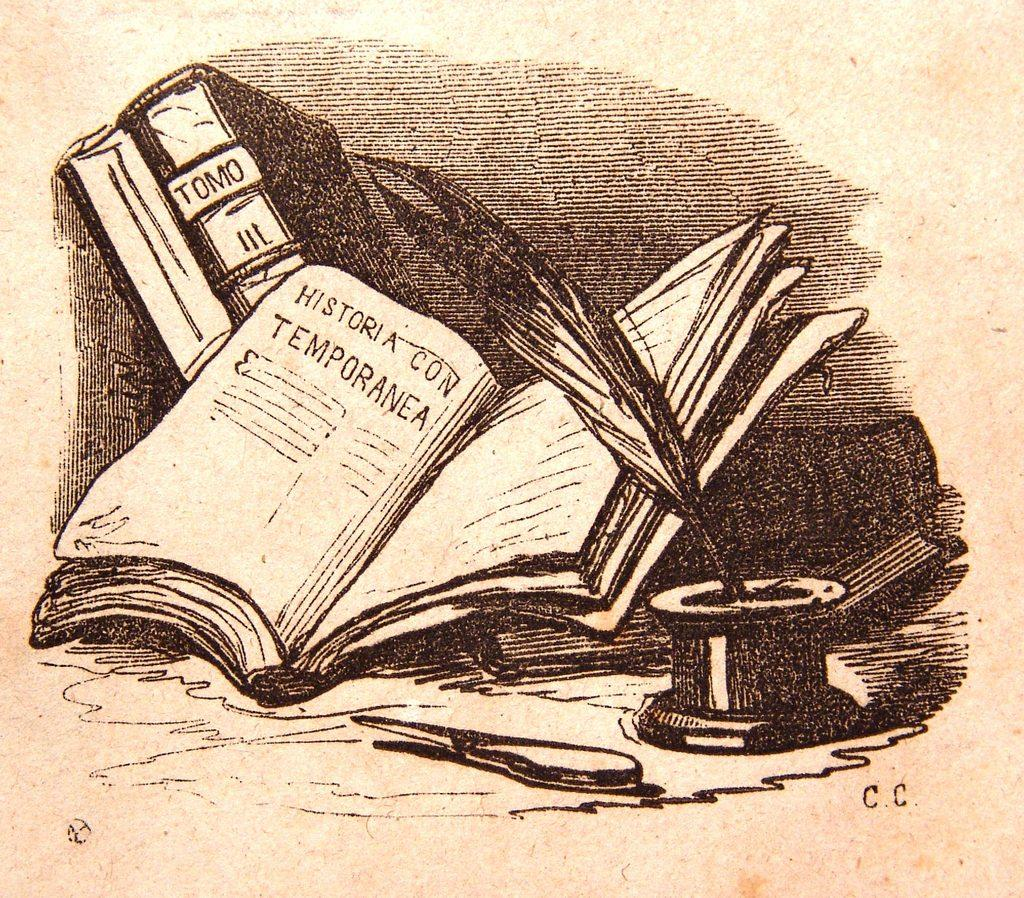<image>
Share a concise interpretation of the image provided. an open book that is pictured on a paper with HISTORIA CON TEMPORANEA inside of the book. 